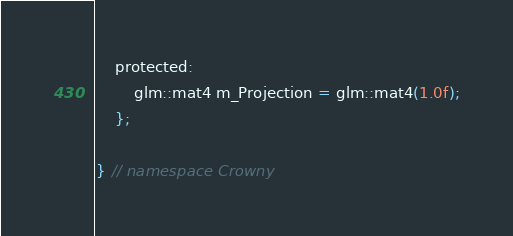<code> <loc_0><loc_0><loc_500><loc_500><_C_>
    protected:
        glm::mat4 m_Projection = glm::mat4(1.0f);
    };

} // namespace Crowny
</code> 